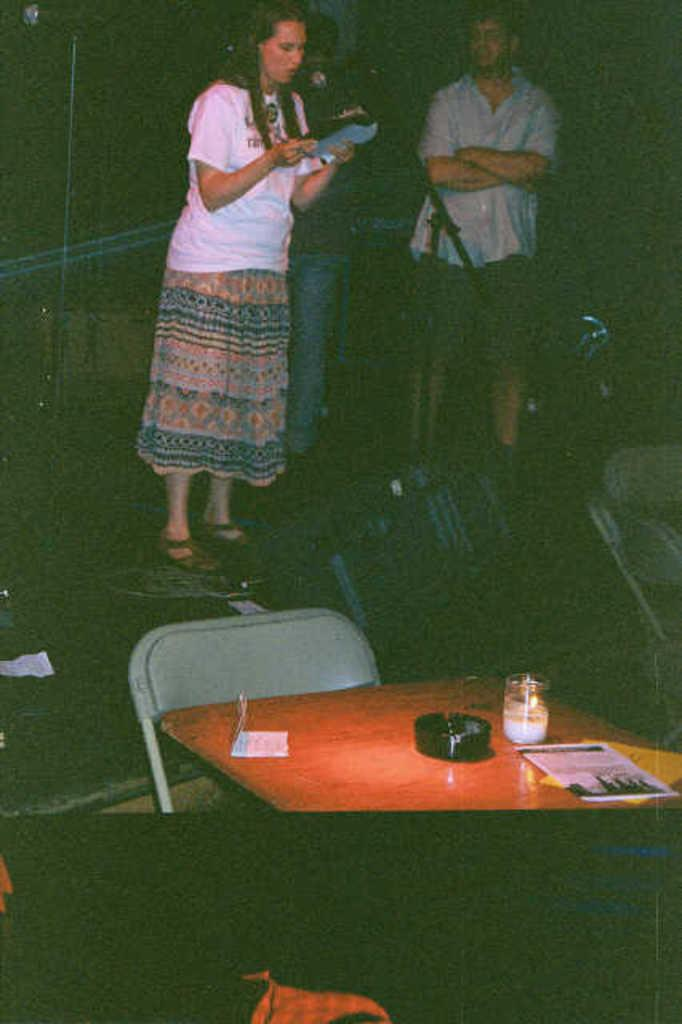How many people are in the image? There are persons standing in the image. What is one person holding in the image? One person is holding a book. What type of furniture is present in the image? There is a table and a chair in the image. What is on the table in the image? A lamp, a book, and papers are present on the table. What device is used for amplifying sound in the image? There is a microphone with a stand in the image. What type of fog can be seen in the image? There is no fog present in the image. How does the cannon affect the persons standing in the image? There is no cannon present in the image, so it cannot affect the persons standing. 